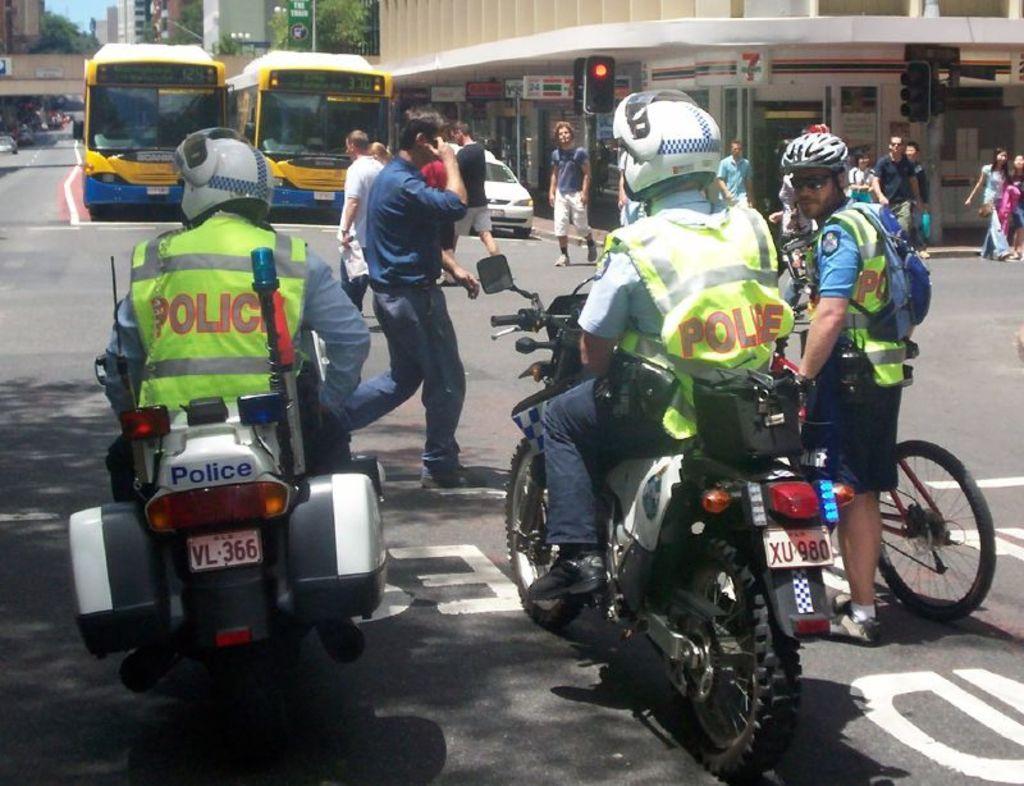Can you describe this image briefly? In this picture we can see a group of people where some are sitting on bikes some are holding bicycle and some are walking on road and in background we can see two buses, building, traffic sign, road, sky. 